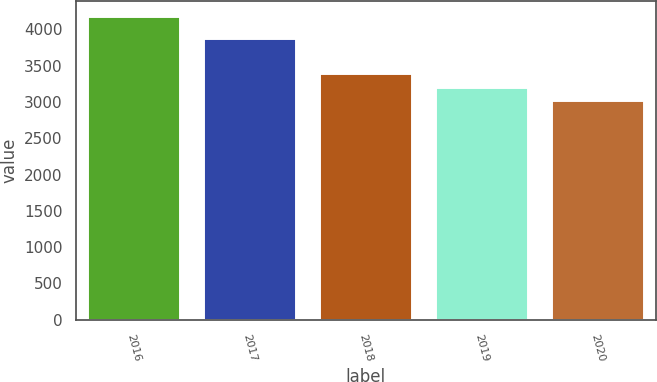Convert chart to OTSL. <chart><loc_0><loc_0><loc_500><loc_500><bar_chart><fcel>2016<fcel>2017<fcel>2018<fcel>2019<fcel>2020<nl><fcel>4181<fcel>3889<fcel>3395<fcel>3202<fcel>3033<nl></chart> 